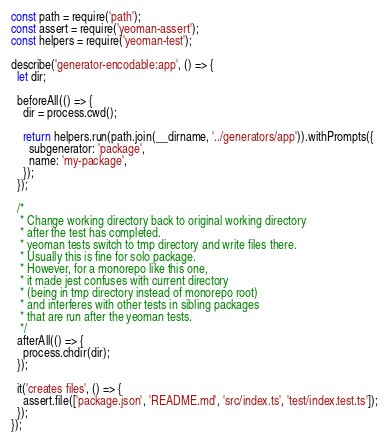<code> <loc_0><loc_0><loc_500><loc_500><_JavaScript_>const path = require('path');
const assert = require('yeoman-assert');
const helpers = require('yeoman-test');

describe('generator-encodable:app', () => {
  let dir;

  beforeAll(() => {
    dir = process.cwd();

    return helpers.run(path.join(__dirname, '../generators/app')).withPrompts({
      subgenerator: 'package',
      name: 'my-package',
    });
  });

  /*
   * Change working directory back to original working directory
   * after the test has completed.
   * yeoman tests switch to tmp directory and write files there.
   * Usually this is fine for solo package.
   * However, for a monorepo like this one,
   * it made jest confuses with current directory
   * (being in tmp directory instead of monorepo root)
   * and interferes with other tests in sibling packages
   * that are run after the yeoman tests.
   */
  afterAll(() => {
    process.chdir(dir);
  });

  it('creates files', () => {
    assert.file(['package.json', 'README.md', 'src/index.ts', 'test/index.test.ts']);
  });
});
</code> 